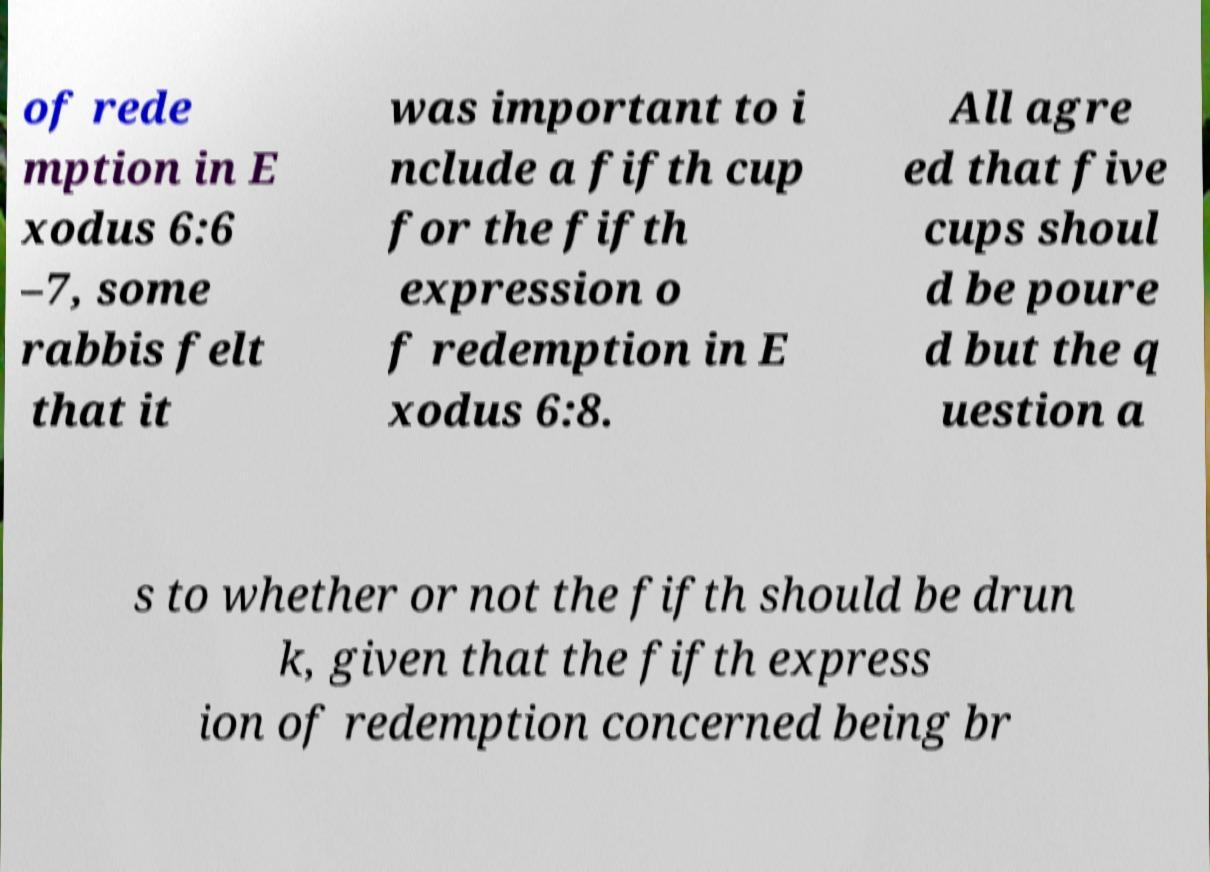Could you extract and type out the text from this image? of rede mption in E xodus 6:6 –7, some rabbis felt that it was important to i nclude a fifth cup for the fifth expression o f redemption in E xodus 6:8. All agre ed that five cups shoul d be poure d but the q uestion a s to whether or not the fifth should be drun k, given that the fifth express ion of redemption concerned being br 